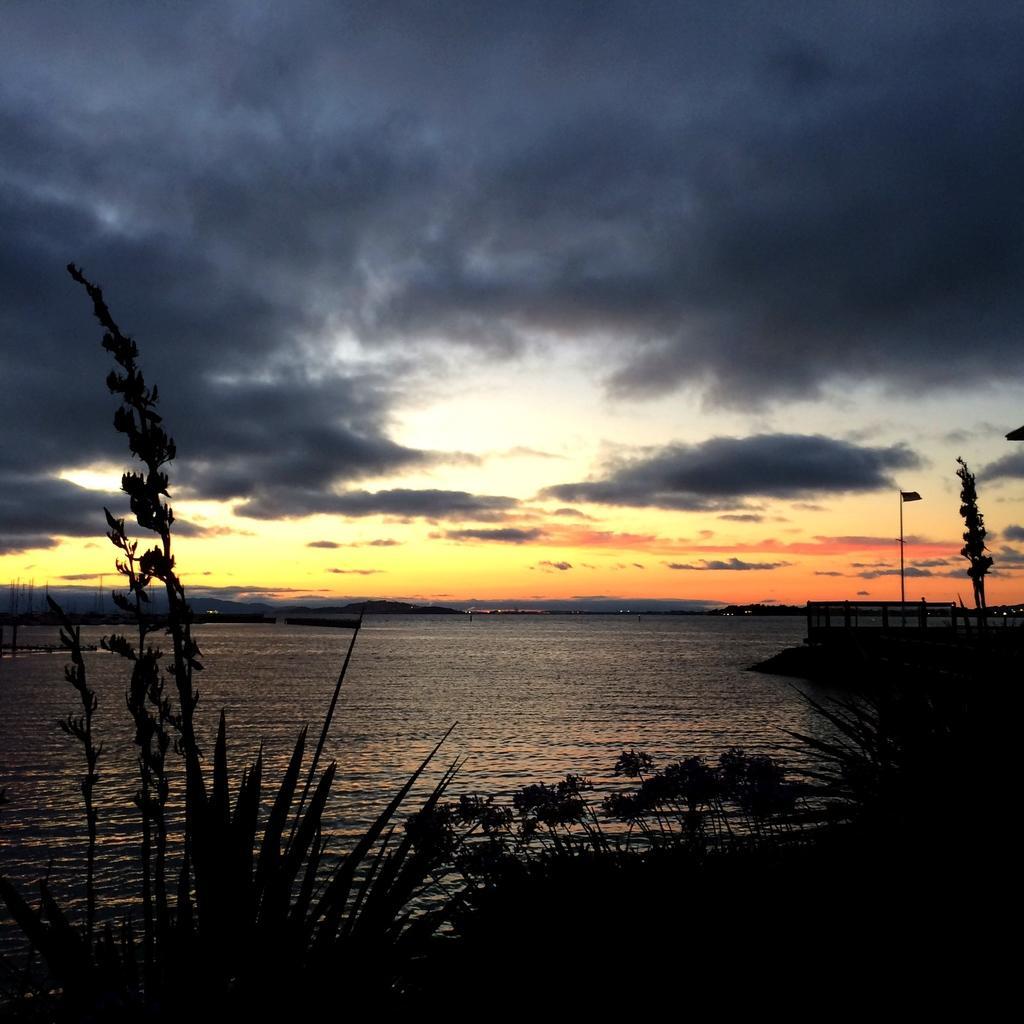Could you give a brief overview of what you see in this image? In this image at the bottom there is a river and in the foreground there are some plants, and in the background there is one pole, tree and fence. At the top there is sky. 